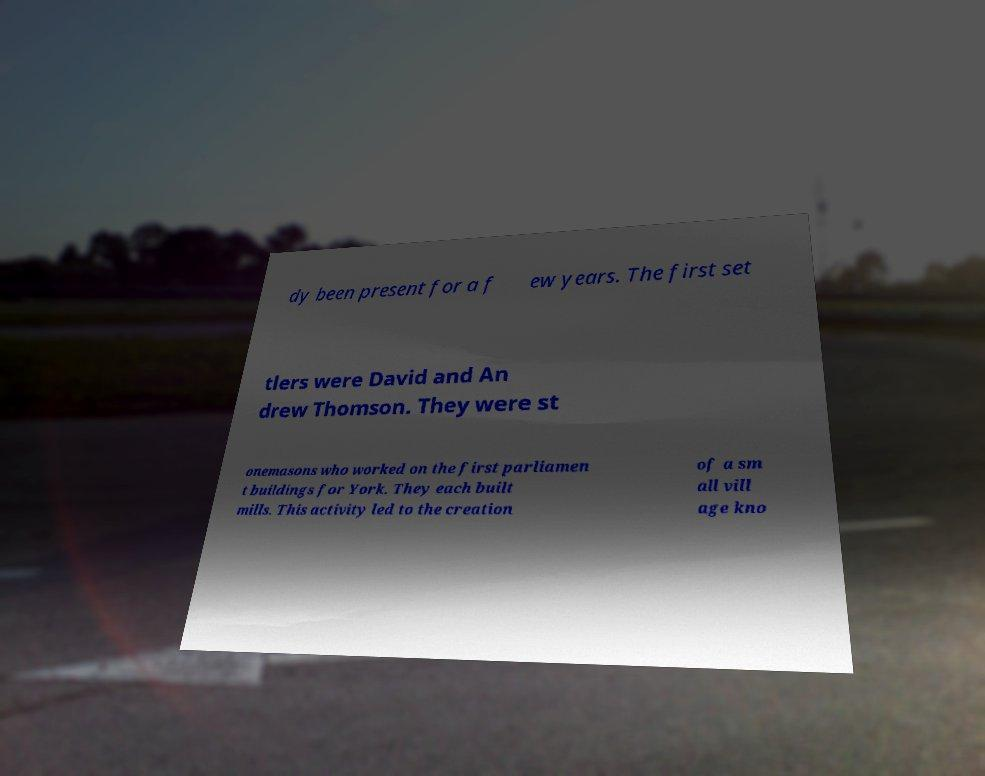For documentation purposes, I need the text within this image transcribed. Could you provide that? dy been present for a f ew years. The first set tlers were David and An drew Thomson. They were st onemasons who worked on the first parliamen t buildings for York. They each built mills. This activity led to the creation of a sm all vill age kno 